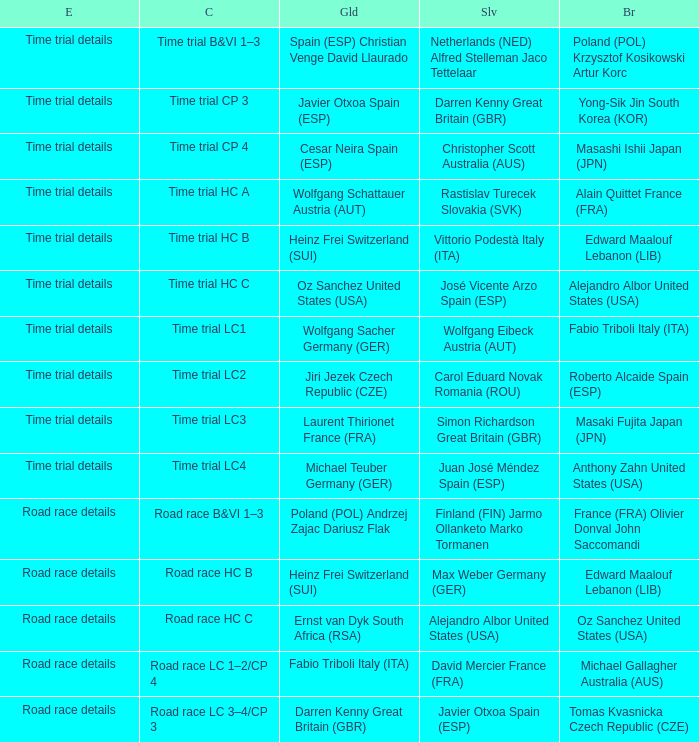What is the event when the class is time trial hc a? Time trial details. 